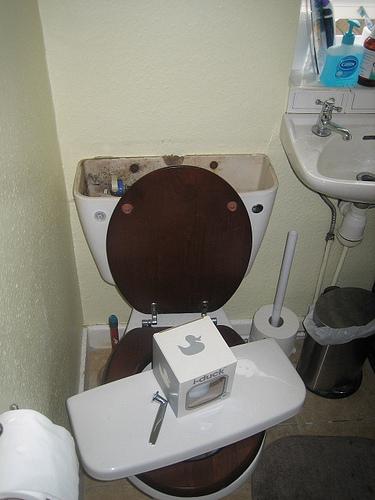Is the toilet being repaired?
Keep it brief. Yes. What color is the hand soap?
Keep it brief. Blue. What color is the toilet seat?
Quick response, please. Brown. What color is the toilet?
Concise answer only. Brown. What type of toilet is this?
Concise answer only. Regular. 